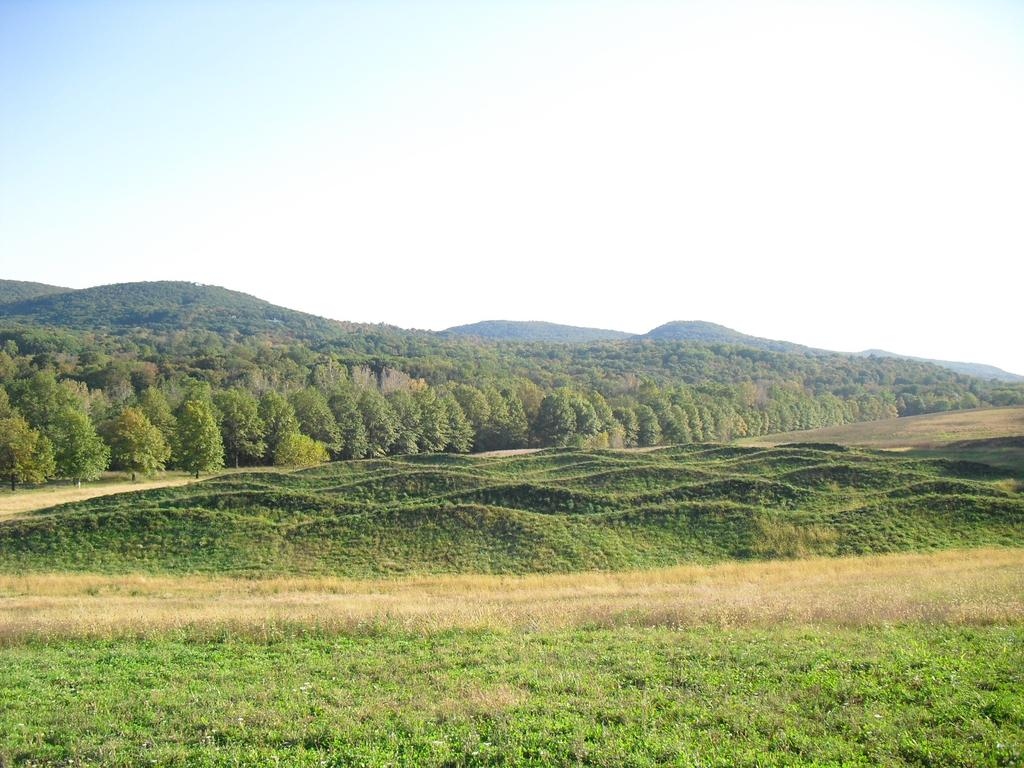What can be seen in the sky in the image? The sky with clouds is visible in the image. What type of natural landforms are present in the image? There are hills in the image. What type of vegetation is present in the image? There are trees in the image. What type of ground cover is present in the image? There is grass in the image. What part of the natural environment is visible in the image? The ground is visible in the image. What type of cork can be seen floating in the sky in the image? There is no cork present in the image; it features the sky with clouds, hills, trees, grass, and the ground. Can you tell me how many boys are visible in the image? There is no boy present in the image. 